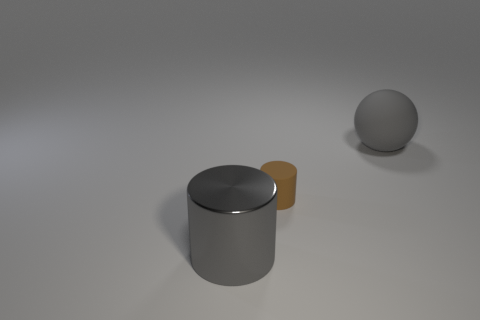Subtract all gray cylinders. How many cylinders are left? 1 Add 1 big rubber blocks. How many objects exist? 4 Subtract 1 balls. How many balls are left? 0 Subtract all cylinders. How many objects are left? 1 Subtract all red cylinders. How many red spheres are left? 0 Subtract all green balls. Subtract all green cubes. How many balls are left? 1 Subtract all big gray spheres. Subtract all matte balls. How many objects are left? 1 Add 3 big rubber spheres. How many big rubber spheres are left? 4 Add 3 brown objects. How many brown objects exist? 4 Subtract 0 purple blocks. How many objects are left? 3 